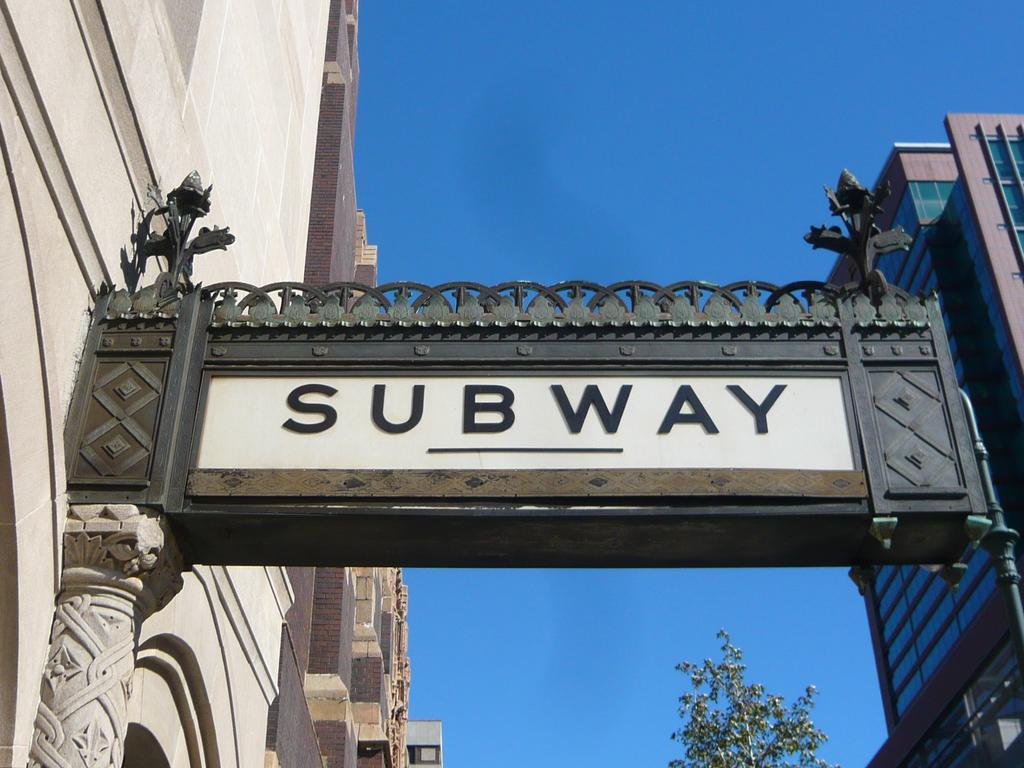What is the main object in the image? There is a name board in the image. What else can be seen in the image besides the name board? There are buildings and a tree in the image. What is visible in the background of the image? The sky is visible in the background of the image. Where is the cart located in the image? There is no cart present in the image. Can you tell me what type of office is shown in the image? There is no office depicted in the image. 